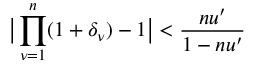Convert formula to latex. <formula><loc_0><loc_0><loc_500><loc_500>\left | \prod _ { \nu = 1 } ^ { n } ( 1 + \delta _ { \nu } ) - 1 \right | < \frac { n u ^ { \prime } } { 1 - n u ^ { \prime } }</formula> 